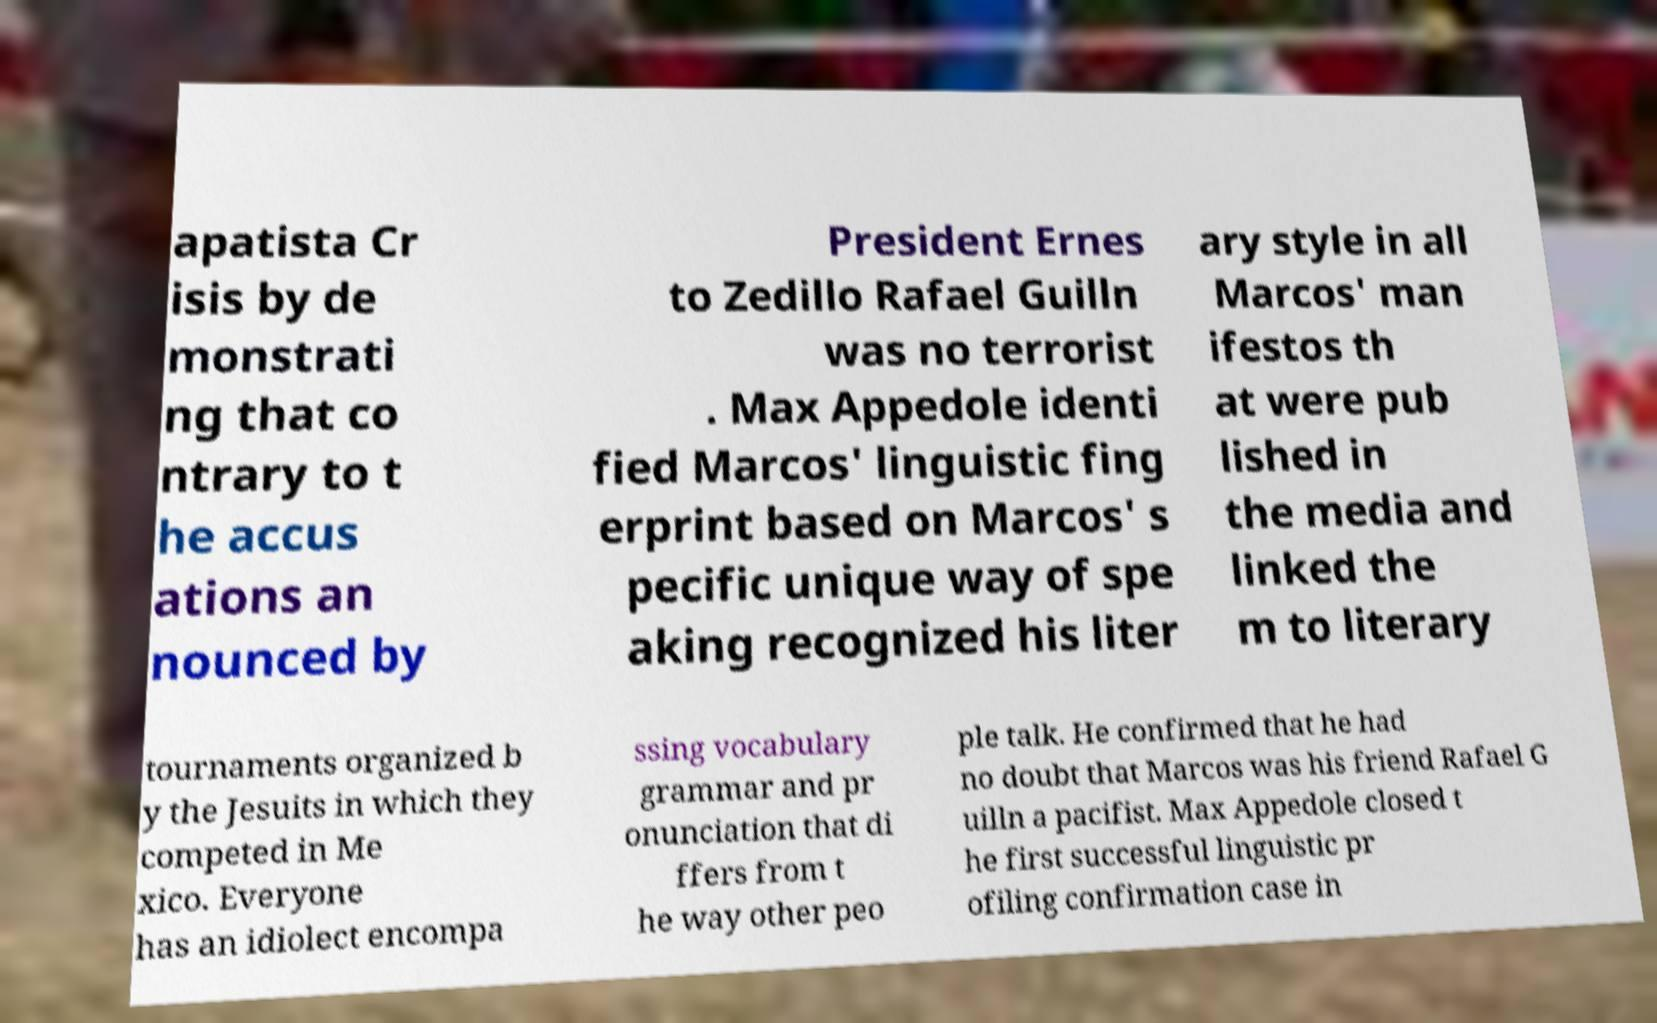I need the written content from this picture converted into text. Can you do that? apatista Cr isis by de monstrati ng that co ntrary to t he accus ations an nounced by President Ernes to Zedillo Rafael Guilln was no terrorist . Max Appedole identi fied Marcos' linguistic fing erprint based on Marcos' s pecific unique way of spe aking recognized his liter ary style in all Marcos' man ifestos th at were pub lished in the media and linked the m to literary tournaments organized b y the Jesuits in which they competed in Me xico. Everyone has an idiolect encompa ssing vocabulary grammar and pr onunciation that di ffers from t he way other peo ple talk. He confirmed that he had no doubt that Marcos was his friend Rafael G uilln a pacifist. Max Appedole closed t he first successful linguistic pr ofiling confirmation case in 